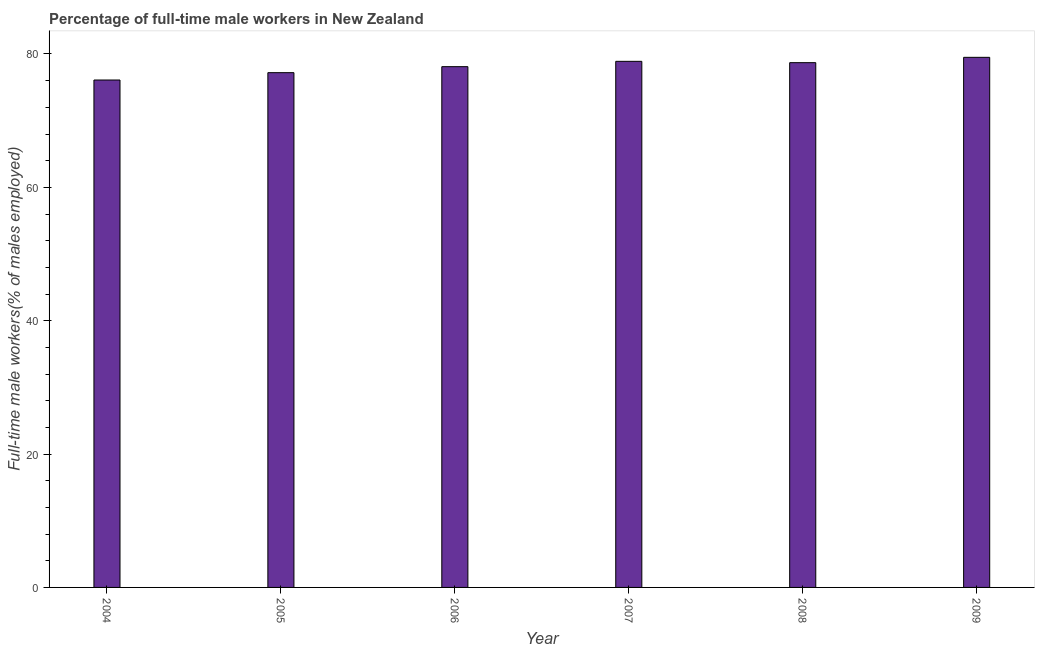Does the graph contain any zero values?
Your response must be concise. No. Does the graph contain grids?
Offer a terse response. No. What is the title of the graph?
Ensure brevity in your answer.  Percentage of full-time male workers in New Zealand. What is the label or title of the Y-axis?
Make the answer very short. Full-time male workers(% of males employed). What is the percentage of full-time male workers in 2005?
Make the answer very short. 77.2. Across all years, what is the maximum percentage of full-time male workers?
Make the answer very short. 79.5. Across all years, what is the minimum percentage of full-time male workers?
Ensure brevity in your answer.  76.1. In which year was the percentage of full-time male workers maximum?
Your answer should be very brief. 2009. What is the sum of the percentage of full-time male workers?
Your answer should be very brief. 468.5. What is the average percentage of full-time male workers per year?
Offer a terse response. 78.08. What is the median percentage of full-time male workers?
Give a very brief answer. 78.4. Is the sum of the percentage of full-time male workers in 2004 and 2009 greater than the maximum percentage of full-time male workers across all years?
Your answer should be very brief. Yes. What is the difference between the highest and the lowest percentage of full-time male workers?
Your answer should be compact. 3.4. In how many years, is the percentage of full-time male workers greater than the average percentage of full-time male workers taken over all years?
Make the answer very short. 4. How many bars are there?
Keep it short and to the point. 6. What is the difference between two consecutive major ticks on the Y-axis?
Your answer should be very brief. 20. Are the values on the major ticks of Y-axis written in scientific E-notation?
Keep it short and to the point. No. What is the Full-time male workers(% of males employed) in 2004?
Offer a terse response. 76.1. What is the Full-time male workers(% of males employed) in 2005?
Offer a very short reply. 77.2. What is the Full-time male workers(% of males employed) in 2006?
Your answer should be very brief. 78.1. What is the Full-time male workers(% of males employed) in 2007?
Offer a very short reply. 78.9. What is the Full-time male workers(% of males employed) in 2008?
Ensure brevity in your answer.  78.7. What is the Full-time male workers(% of males employed) of 2009?
Make the answer very short. 79.5. What is the difference between the Full-time male workers(% of males employed) in 2004 and 2005?
Keep it short and to the point. -1.1. What is the difference between the Full-time male workers(% of males employed) in 2004 and 2006?
Offer a very short reply. -2. What is the difference between the Full-time male workers(% of males employed) in 2005 and 2009?
Your answer should be compact. -2.3. What is the difference between the Full-time male workers(% of males employed) in 2006 and 2007?
Keep it short and to the point. -0.8. What is the difference between the Full-time male workers(% of males employed) in 2006 and 2008?
Offer a very short reply. -0.6. What is the difference between the Full-time male workers(% of males employed) in 2006 and 2009?
Your answer should be compact. -1.4. What is the difference between the Full-time male workers(% of males employed) in 2007 and 2009?
Ensure brevity in your answer.  -0.6. What is the ratio of the Full-time male workers(% of males employed) in 2004 to that in 2005?
Make the answer very short. 0.99. What is the ratio of the Full-time male workers(% of males employed) in 2004 to that in 2008?
Offer a terse response. 0.97. What is the ratio of the Full-time male workers(% of males employed) in 2004 to that in 2009?
Your answer should be very brief. 0.96. What is the ratio of the Full-time male workers(% of males employed) in 2005 to that in 2008?
Provide a succinct answer. 0.98. What is the ratio of the Full-time male workers(% of males employed) in 2006 to that in 2007?
Your response must be concise. 0.99. What is the ratio of the Full-time male workers(% of males employed) in 2006 to that in 2008?
Provide a succinct answer. 0.99. What is the ratio of the Full-time male workers(% of males employed) in 2007 to that in 2008?
Ensure brevity in your answer.  1. What is the ratio of the Full-time male workers(% of males employed) in 2008 to that in 2009?
Keep it short and to the point. 0.99. 